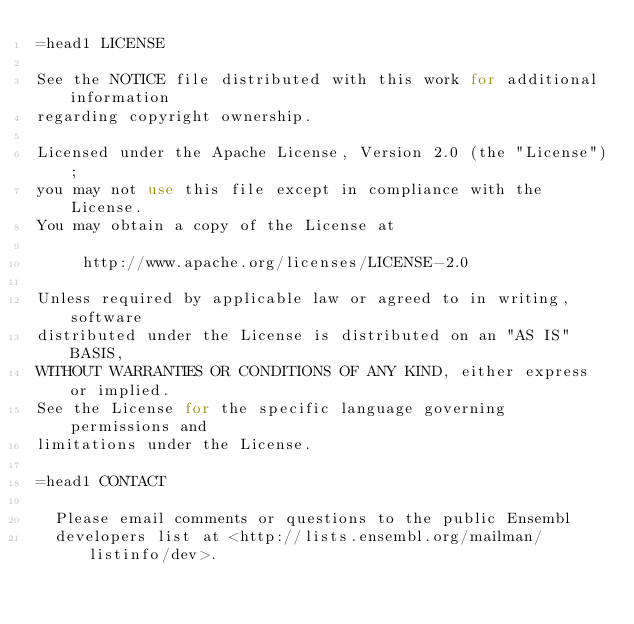Convert code to text. <code><loc_0><loc_0><loc_500><loc_500><_Perl_>=head1 LICENSE

See the NOTICE file distributed with this work for additional information
regarding copyright ownership.

Licensed under the Apache License, Version 2.0 (the "License");
you may not use this file except in compliance with the License.
You may obtain a copy of the License at

     http://www.apache.org/licenses/LICENSE-2.0

Unless required by applicable law or agreed to in writing, software
distributed under the License is distributed on an "AS IS" BASIS,
WITHOUT WARRANTIES OR CONDITIONS OF ANY KIND, either express or implied.
See the License for the specific language governing permissions and
limitations under the License.

=head1 CONTACT

  Please email comments or questions to the public Ensembl
  developers list at <http://lists.ensembl.org/mailman/listinfo/dev>.
</code> 